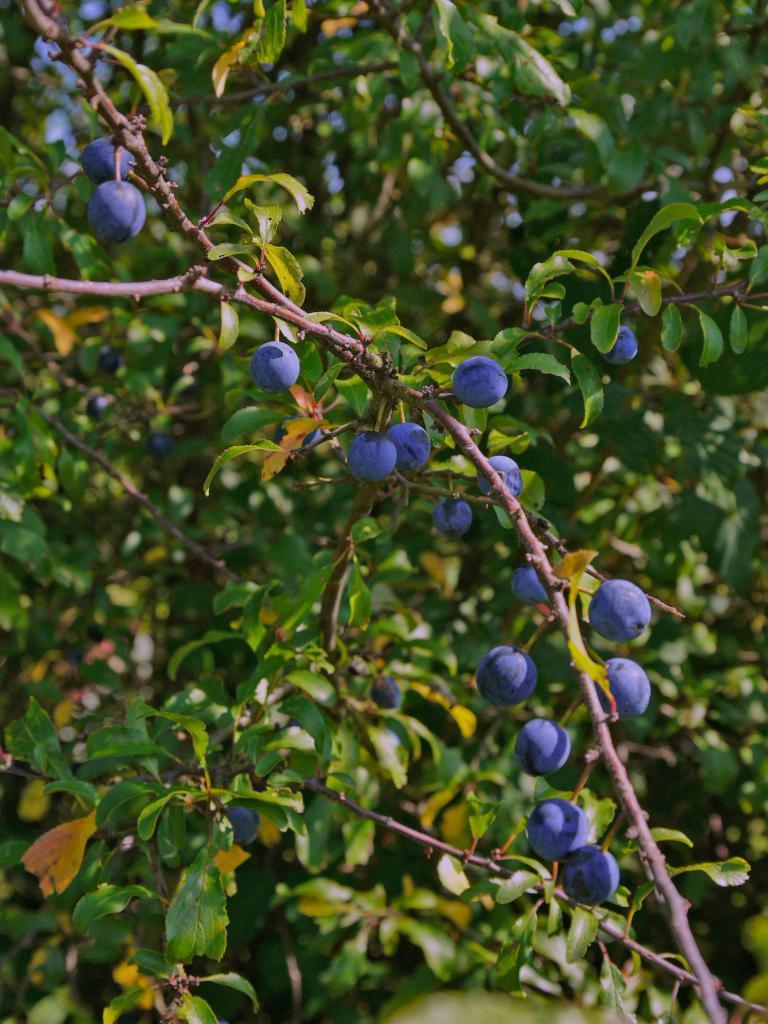Describe this image in one or two sentences. In this image there are flowers on the plants. In the background there are trees. 